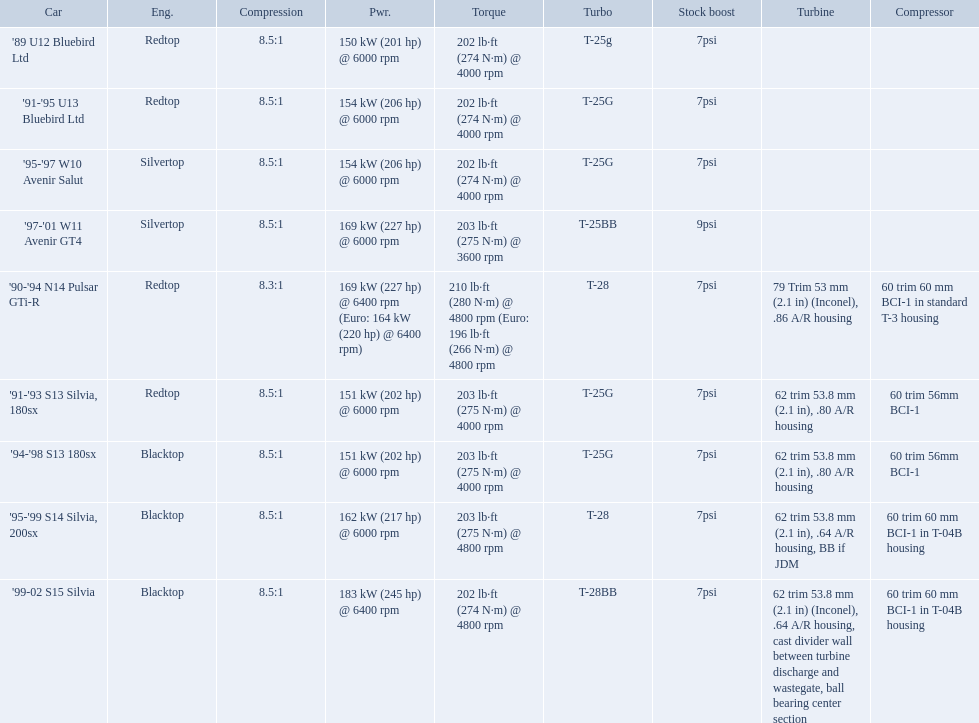What are the psi's? 7psi, 7psi, 7psi, 9psi, 7psi, 7psi, 7psi, 7psi, 7psi. What are the number(s) greater than 7? 9psi. Which car has that number? '97-'01 W11 Avenir GT4. What are all the cars? '89 U12 Bluebird Ltd, '91-'95 U13 Bluebird Ltd, '95-'97 W10 Avenir Salut, '97-'01 W11 Avenir GT4, '90-'94 N14 Pulsar GTi-R, '91-'93 S13 Silvia, 180sx, '94-'98 S13 180sx, '95-'99 S14 Silvia, 200sx, '99-02 S15 Silvia. What are their stock boosts? 7psi, 7psi, 7psi, 9psi, 7psi, 7psi, 7psi, 7psi, 7psi. And which car has the highest stock boost? '97-'01 W11 Avenir GT4. Which cars list turbine details? '90-'94 N14 Pulsar GTi-R, '91-'93 S13 Silvia, 180sx, '94-'98 S13 180sx, '95-'99 S14 Silvia, 200sx, '99-02 S15 Silvia. Which of these hit their peak hp at the highest rpm? '90-'94 N14 Pulsar GTi-R, '99-02 S15 Silvia. Of those what is the compression of the only engine that isn't blacktop?? 8.3:1. Which of the cars uses the redtop engine? '89 U12 Bluebird Ltd, '91-'95 U13 Bluebird Ltd, '90-'94 N14 Pulsar GTi-R, '91-'93 S13 Silvia, 180sx. Of these, has more than 220 horsepower? '90-'94 N14 Pulsar GTi-R. What is the compression ratio of this car? 8.3:1. 